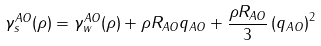Convert formula to latex. <formula><loc_0><loc_0><loc_500><loc_500>\gamma ^ { A O } _ { s } ( \rho ) = \gamma ^ { A O } _ { w } ( \rho ) + \rho R _ { A O } q _ { A O } + \frac { \rho R _ { A O } } { 3 } \left ( q _ { A O } \right ) ^ { 2 }</formula> 